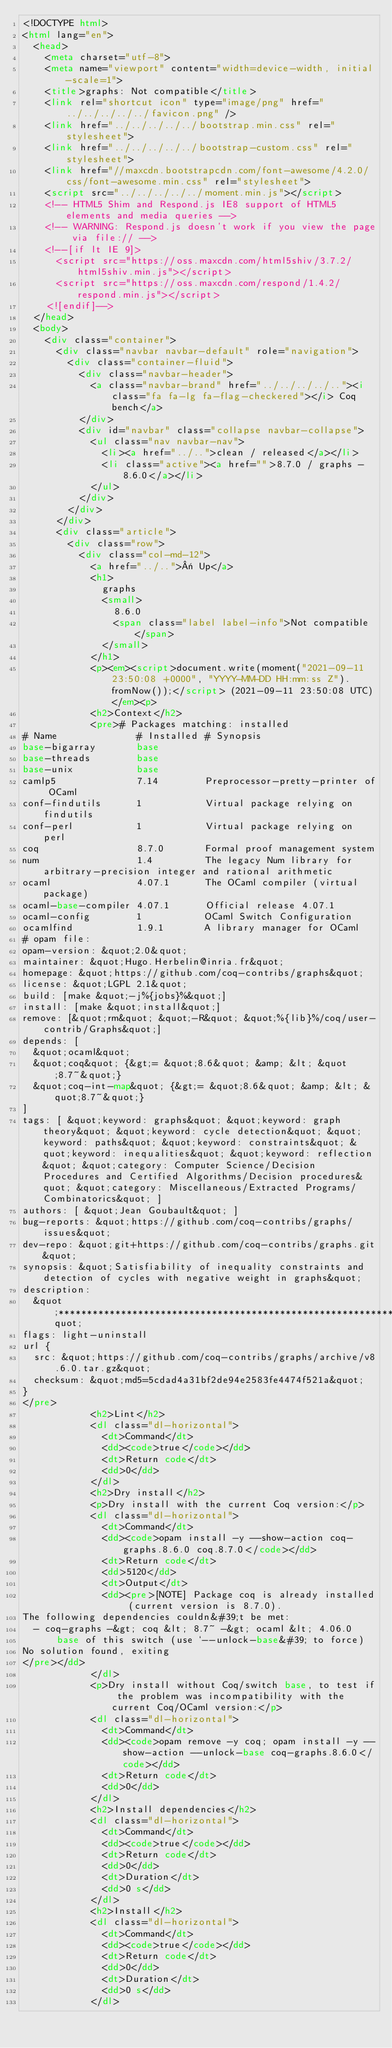<code> <loc_0><loc_0><loc_500><loc_500><_HTML_><!DOCTYPE html>
<html lang="en">
  <head>
    <meta charset="utf-8">
    <meta name="viewport" content="width=device-width, initial-scale=1">
    <title>graphs: Not compatible</title>
    <link rel="shortcut icon" type="image/png" href="../../../../../favicon.png" />
    <link href="../../../../../bootstrap.min.css" rel="stylesheet">
    <link href="../../../../../bootstrap-custom.css" rel="stylesheet">
    <link href="//maxcdn.bootstrapcdn.com/font-awesome/4.2.0/css/font-awesome.min.css" rel="stylesheet">
    <script src="../../../../../moment.min.js"></script>
    <!-- HTML5 Shim and Respond.js IE8 support of HTML5 elements and media queries -->
    <!-- WARNING: Respond.js doesn't work if you view the page via file:// -->
    <!--[if lt IE 9]>
      <script src="https://oss.maxcdn.com/html5shiv/3.7.2/html5shiv.min.js"></script>
      <script src="https://oss.maxcdn.com/respond/1.4.2/respond.min.js"></script>
    <![endif]-->
  </head>
  <body>
    <div class="container">
      <div class="navbar navbar-default" role="navigation">
        <div class="container-fluid">
          <div class="navbar-header">
            <a class="navbar-brand" href="../../../../.."><i class="fa fa-lg fa-flag-checkered"></i> Coq bench</a>
          </div>
          <div id="navbar" class="collapse navbar-collapse">
            <ul class="nav navbar-nav">
              <li><a href="../..">clean / released</a></li>
              <li class="active"><a href="">8.7.0 / graphs - 8.6.0</a></li>
            </ul>
          </div>
        </div>
      </div>
      <div class="article">
        <div class="row">
          <div class="col-md-12">
            <a href="../..">« Up</a>
            <h1>
              graphs
              <small>
                8.6.0
                <span class="label label-info">Not compatible</span>
              </small>
            </h1>
            <p><em><script>document.write(moment("2021-09-11 23:50:08 +0000", "YYYY-MM-DD HH:mm:ss Z").fromNow());</script> (2021-09-11 23:50:08 UTC)</em><p>
            <h2>Context</h2>
            <pre># Packages matching: installed
# Name              # Installed # Synopsis
base-bigarray       base
base-threads        base
base-unix           base
camlp5              7.14        Preprocessor-pretty-printer of OCaml
conf-findutils      1           Virtual package relying on findutils
conf-perl           1           Virtual package relying on perl
coq                 8.7.0       Formal proof management system
num                 1.4         The legacy Num library for arbitrary-precision integer and rational arithmetic
ocaml               4.07.1      The OCaml compiler (virtual package)
ocaml-base-compiler 4.07.1      Official release 4.07.1
ocaml-config        1           OCaml Switch Configuration
ocamlfind           1.9.1       A library manager for OCaml
# opam file:
opam-version: &quot;2.0&quot;
maintainer: &quot;Hugo.Herbelin@inria.fr&quot;
homepage: &quot;https://github.com/coq-contribs/graphs&quot;
license: &quot;LGPL 2.1&quot;
build: [make &quot;-j%{jobs}%&quot;]
install: [make &quot;install&quot;]
remove: [&quot;rm&quot; &quot;-R&quot; &quot;%{lib}%/coq/user-contrib/Graphs&quot;]
depends: [
  &quot;ocaml&quot;
  &quot;coq&quot; {&gt;= &quot;8.6&quot; &amp; &lt; &quot;8.7~&quot;}
  &quot;coq-int-map&quot; {&gt;= &quot;8.6&quot; &amp; &lt; &quot;8.7~&quot;}
]
tags: [ &quot;keyword: graphs&quot; &quot;keyword: graph theory&quot; &quot;keyword: cycle detection&quot; &quot;keyword: paths&quot; &quot;keyword: constraints&quot; &quot;keyword: inequalities&quot; &quot;keyword: reflection&quot; &quot;category: Computer Science/Decision Procedures and Certified Algorithms/Decision procedures&quot; &quot;category: Miscellaneous/Extracted Programs/Combinatorics&quot; ]
authors: [ &quot;Jean Goubault&quot; ]
bug-reports: &quot;https://github.com/coq-contribs/graphs/issues&quot;
dev-repo: &quot;git+https://github.com/coq-contribs/graphs.git&quot;
synopsis: &quot;Satisfiability of inequality constraints and detection of cycles with negative weight in graphs&quot;
description:
  &quot;*******************************************************************&quot;
flags: light-uninstall
url {
  src: &quot;https://github.com/coq-contribs/graphs/archive/v8.6.0.tar.gz&quot;
  checksum: &quot;md5=5cdad4a31bf2de94e2583fe4474f521a&quot;
}
</pre>
            <h2>Lint</h2>
            <dl class="dl-horizontal">
              <dt>Command</dt>
              <dd><code>true</code></dd>
              <dt>Return code</dt>
              <dd>0</dd>
            </dl>
            <h2>Dry install</h2>
            <p>Dry install with the current Coq version:</p>
            <dl class="dl-horizontal">
              <dt>Command</dt>
              <dd><code>opam install -y --show-action coq-graphs.8.6.0 coq.8.7.0</code></dd>
              <dt>Return code</dt>
              <dd>5120</dd>
              <dt>Output</dt>
              <dd><pre>[NOTE] Package coq is already installed (current version is 8.7.0).
The following dependencies couldn&#39;t be met:
  - coq-graphs -&gt; coq &lt; 8.7~ -&gt; ocaml &lt; 4.06.0
      base of this switch (use `--unlock-base&#39; to force)
No solution found, exiting
</pre></dd>
            </dl>
            <p>Dry install without Coq/switch base, to test if the problem was incompatibility with the current Coq/OCaml version:</p>
            <dl class="dl-horizontal">
              <dt>Command</dt>
              <dd><code>opam remove -y coq; opam install -y --show-action --unlock-base coq-graphs.8.6.0</code></dd>
              <dt>Return code</dt>
              <dd>0</dd>
            </dl>
            <h2>Install dependencies</h2>
            <dl class="dl-horizontal">
              <dt>Command</dt>
              <dd><code>true</code></dd>
              <dt>Return code</dt>
              <dd>0</dd>
              <dt>Duration</dt>
              <dd>0 s</dd>
            </dl>
            <h2>Install</h2>
            <dl class="dl-horizontal">
              <dt>Command</dt>
              <dd><code>true</code></dd>
              <dt>Return code</dt>
              <dd>0</dd>
              <dt>Duration</dt>
              <dd>0 s</dd>
            </dl></code> 